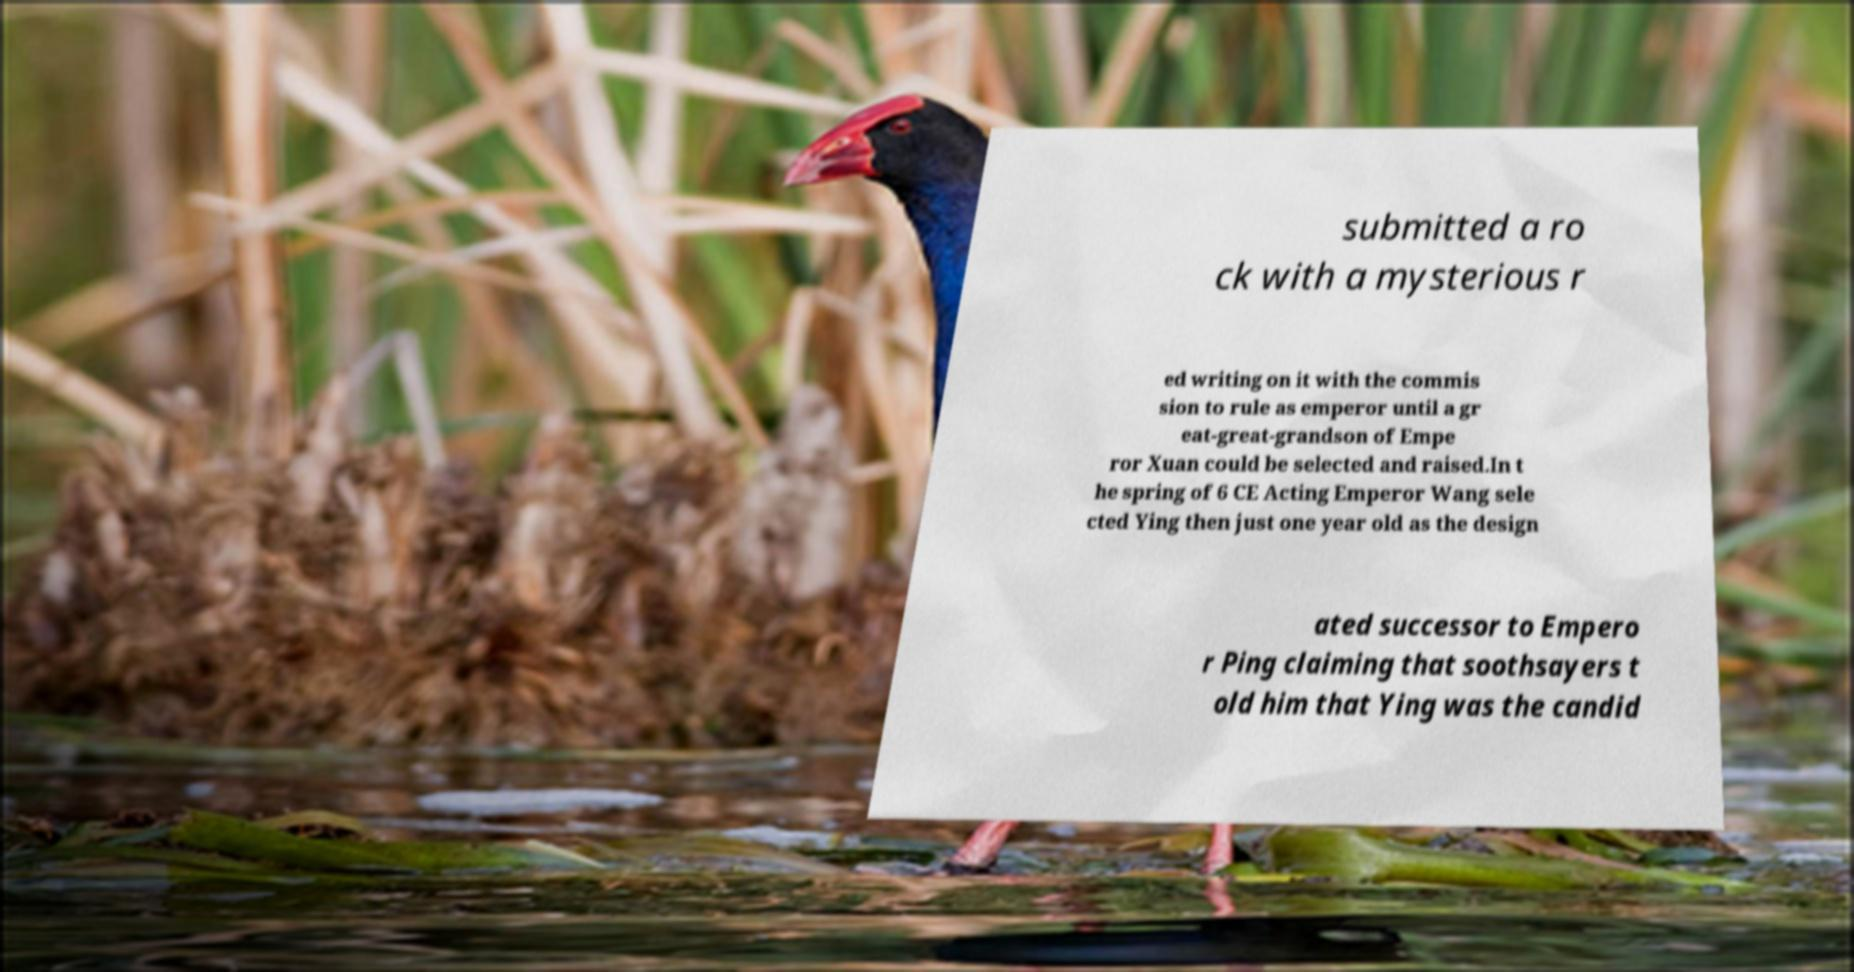Please identify and transcribe the text found in this image. submitted a ro ck with a mysterious r ed writing on it with the commis sion to rule as emperor until a gr eat-great-grandson of Empe ror Xuan could be selected and raised.In t he spring of 6 CE Acting Emperor Wang sele cted Ying then just one year old as the design ated successor to Empero r Ping claiming that soothsayers t old him that Ying was the candid 